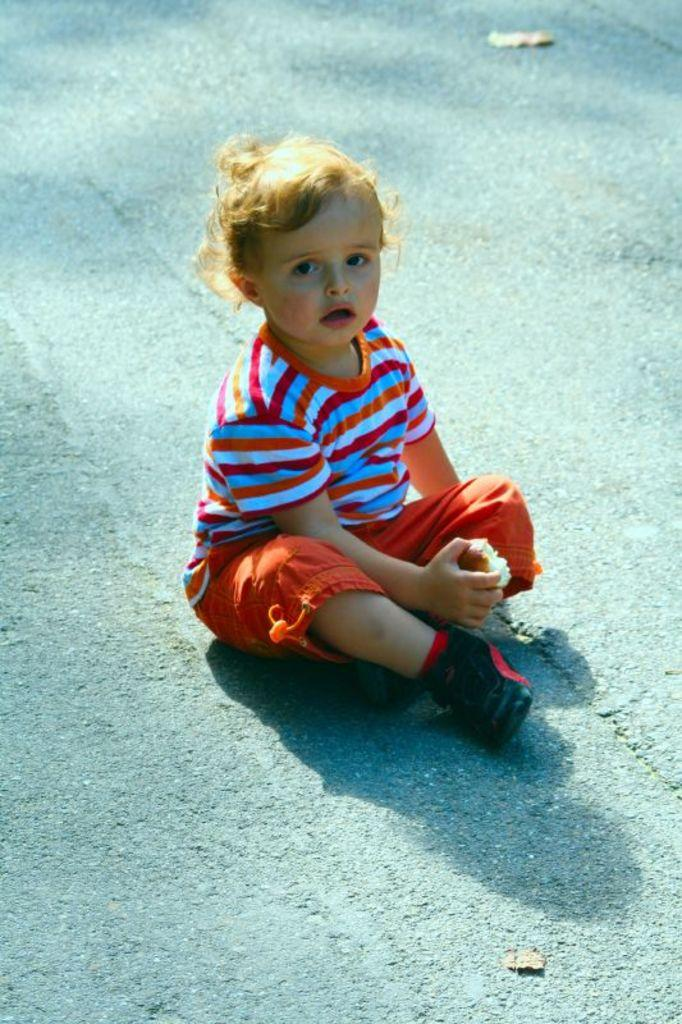Who is the main subject in the image? There is a boy in the image. What is the boy doing in the image? The boy is sitting on the road. What type of clothing is the boy wearing? The boy is wearing a T-shirt, shorts, and shoes. What is the boy holding in his hand? The boy is holding a food item in his hand. Can you see the seashore in the background of the image? There is no seashore visible in the image; it features a boy sitting on the road. Is the boy walking or running in the image? The boy is sitting on the road, so he is not walking or running in the image. 